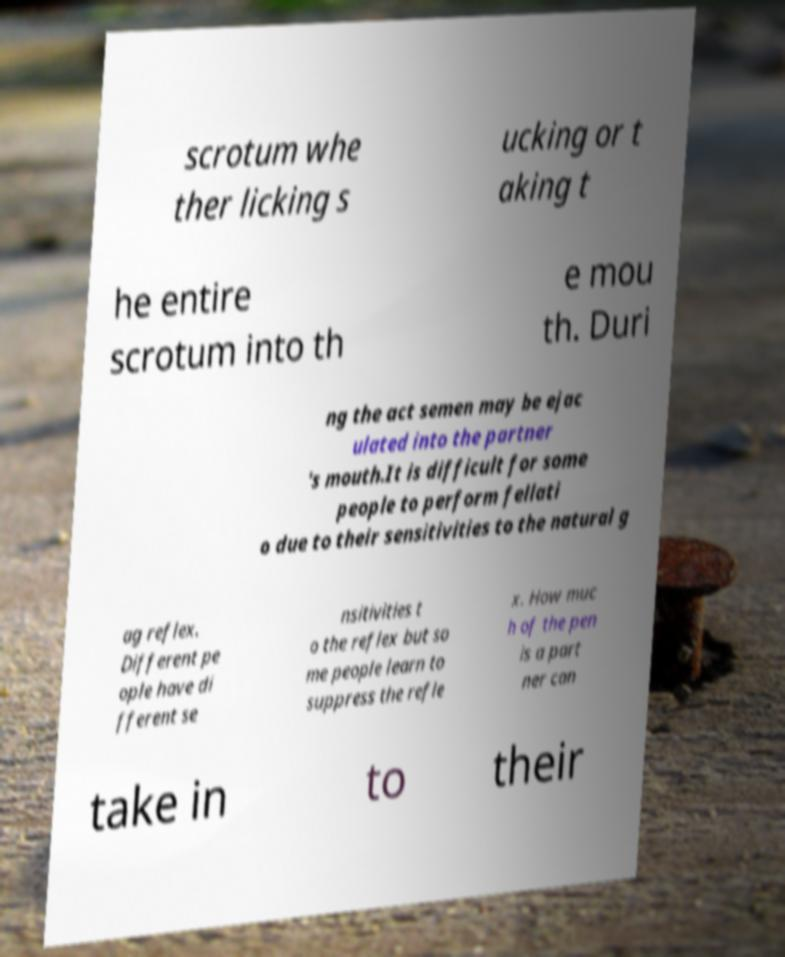Can you accurately transcribe the text from the provided image for me? scrotum whe ther licking s ucking or t aking t he entire scrotum into th e mou th. Duri ng the act semen may be ejac ulated into the partner 's mouth.It is difficult for some people to perform fellati o due to their sensitivities to the natural g ag reflex. Different pe ople have di fferent se nsitivities t o the reflex but so me people learn to suppress the refle x. How muc h of the pen is a part ner can take in to their 